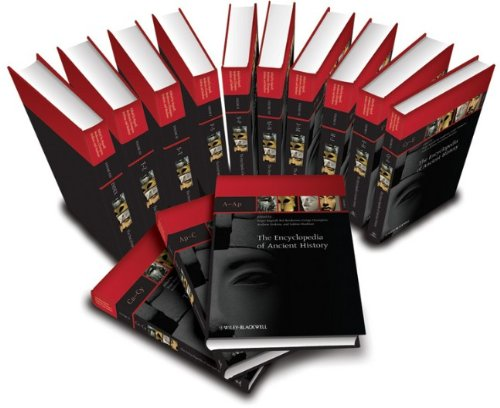How are the volumes organized in this encyclopedia? The volumes of 'The Encyclopedia of Ancient History' are organized alphabetically, with each volume covering specific ranges of topics and themes. This arrangement facilitates easy reference and systematic study of ancient historical matters. 